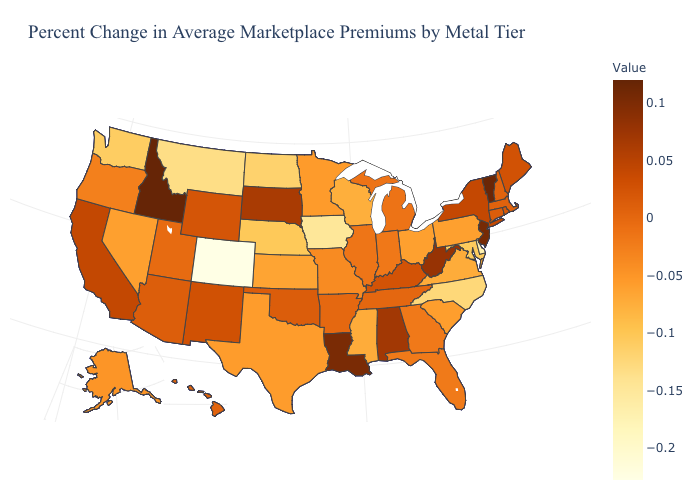Does Colorado have the lowest value in the USA?
Quick response, please. Yes. Does the map have missing data?
Be succinct. No. Does Maine have a higher value than Idaho?
Be succinct. No. Among the states that border Nebraska , does Missouri have the highest value?
Give a very brief answer. No. Is the legend a continuous bar?
Be succinct. Yes. 